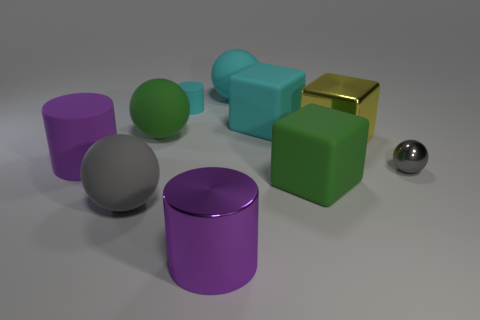Subtract all blocks. How many objects are left? 7 Add 6 green rubber things. How many green rubber things are left? 8 Add 5 large purple cylinders. How many large purple cylinders exist? 7 Subtract 0 yellow balls. How many objects are left? 10 Subtract all green rubber spheres. Subtract all purple metallic objects. How many objects are left? 8 